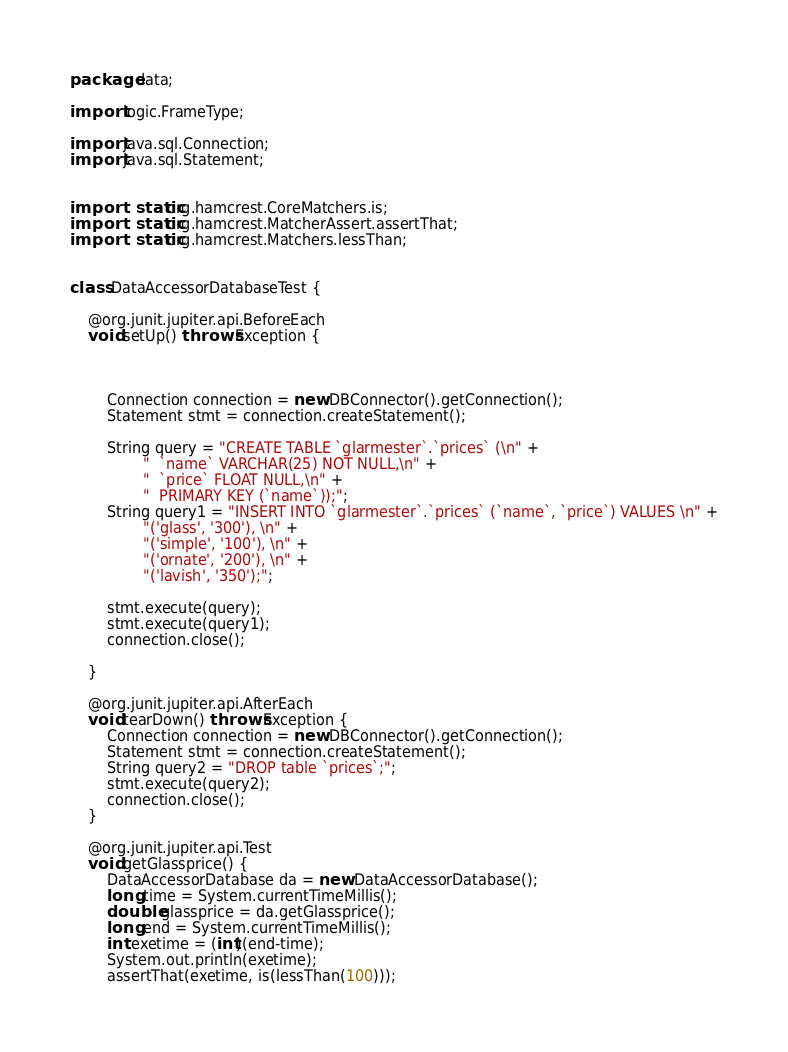Convert code to text. <code><loc_0><loc_0><loc_500><loc_500><_Java_>package data;

import logic.FrameType;

import java.sql.Connection;
import java.sql.Statement;


import static org.hamcrest.CoreMatchers.is;
import static org.hamcrest.MatcherAssert.assertThat;
import static org.hamcrest.Matchers.lessThan;


class DataAccessorDatabaseTest {

    @org.junit.jupiter.api.BeforeEach
    void setUp() throws Exception {



        Connection connection = new DBConnector().getConnection();
        Statement stmt = connection.createStatement();

        String query = "CREATE TABLE `glarmester`.`prices` (\n" +
                "  `name` VARCHAR(25) NOT NULL,\n" +
                "  `price` FLOAT NULL,\n" +
                "  PRIMARY KEY (`name`));";
        String query1 = "INSERT INTO `glarmester`.`prices` (`name`, `price`) VALUES \n" +
                "('glass', '300'), \n" +
                "('simple', '100'), \n" +
                "('ornate', '200'), \n" +
                "('lavish', '350');";

        stmt.execute(query);
        stmt.execute(query1);
        connection.close();

    }

    @org.junit.jupiter.api.AfterEach
    void tearDown() throws Exception {
        Connection connection = new DBConnector().getConnection();
        Statement stmt = connection.createStatement();
        String query2 = "DROP table `prices`;";
        stmt.execute(query2);
        connection.close();
    }

    @org.junit.jupiter.api.Test
    void getGlassprice() {
        DataAccessorDatabase da = new DataAccessorDatabase();
        long time = System.currentTimeMillis();
        double glassprice = da.getGlassprice();
        long end = System.currentTimeMillis();
        int exetime = (int)(end-time);
        System.out.println(exetime);
        assertThat(exetime, is(lessThan(100)));</code> 